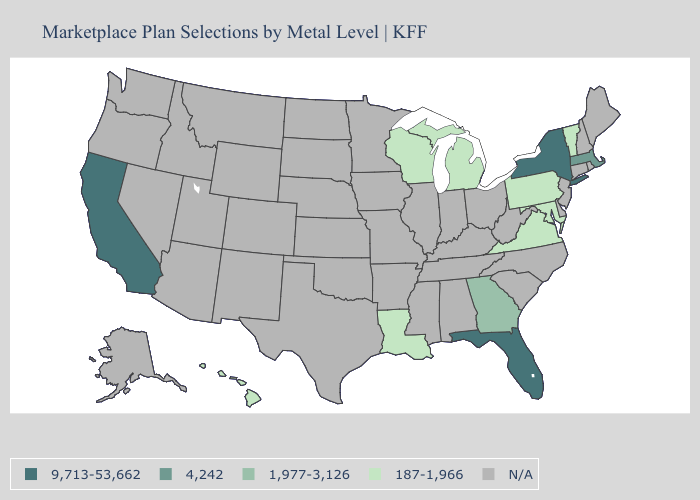What is the value of Iowa?
Answer briefly. N/A. What is the highest value in the Northeast ?
Write a very short answer. 9,713-53,662. What is the highest value in the MidWest ?
Be succinct. 187-1,966. What is the lowest value in the USA?
Concise answer only. 187-1,966. Name the states that have a value in the range 9,713-53,662?
Keep it brief. California, Florida, New York. What is the lowest value in states that border South Carolina?
Concise answer only. 1,977-3,126. Name the states that have a value in the range N/A?
Give a very brief answer. Alabama, Alaska, Arizona, Arkansas, Colorado, Connecticut, Delaware, Idaho, Illinois, Indiana, Iowa, Kansas, Kentucky, Maine, Minnesota, Mississippi, Missouri, Montana, Nebraska, Nevada, New Hampshire, New Jersey, New Mexico, North Carolina, North Dakota, Ohio, Oklahoma, Oregon, Rhode Island, South Carolina, South Dakota, Tennessee, Texas, Utah, Washington, West Virginia, Wyoming. Name the states that have a value in the range 4,242?
Answer briefly. Massachusetts. What is the value of Louisiana?
Give a very brief answer. 187-1,966. Does Louisiana have the lowest value in the USA?
Short answer required. Yes. Does the first symbol in the legend represent the smallest category?
Keep it brief. No. What is the highest value in states that border Florida?
Quick response, please. 1,977-3,126. Name the states that have a value in the range 1,977-3,126?
Be succinct. Georgia. Name the states that have a value in the range 9,713-53,662?
Concise answer only. California, Florida, New York. 